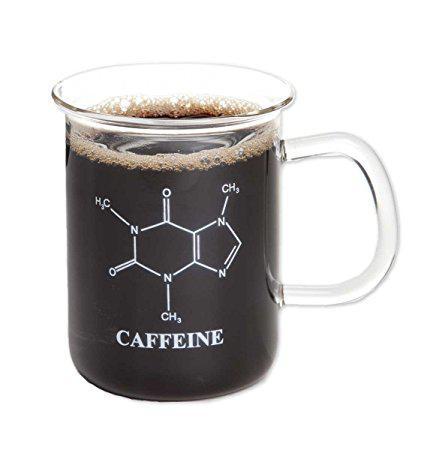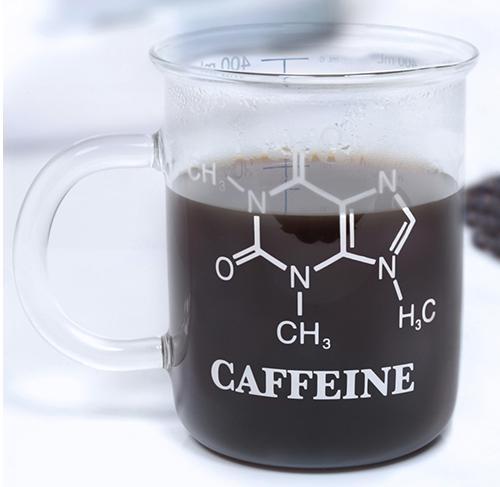The first image is the image on the left, the second image is the image on the right. Given the left and right images, does the statement "Both beakers are full of coffee." hold true? Answer yes or no. Yes. The first image is the image on the left, the second image is the image on the right. Examine the images to the left and right. Is the description "The container in each of the images is filled with dark liquid." accurate? Answer yes or no. Yes. 